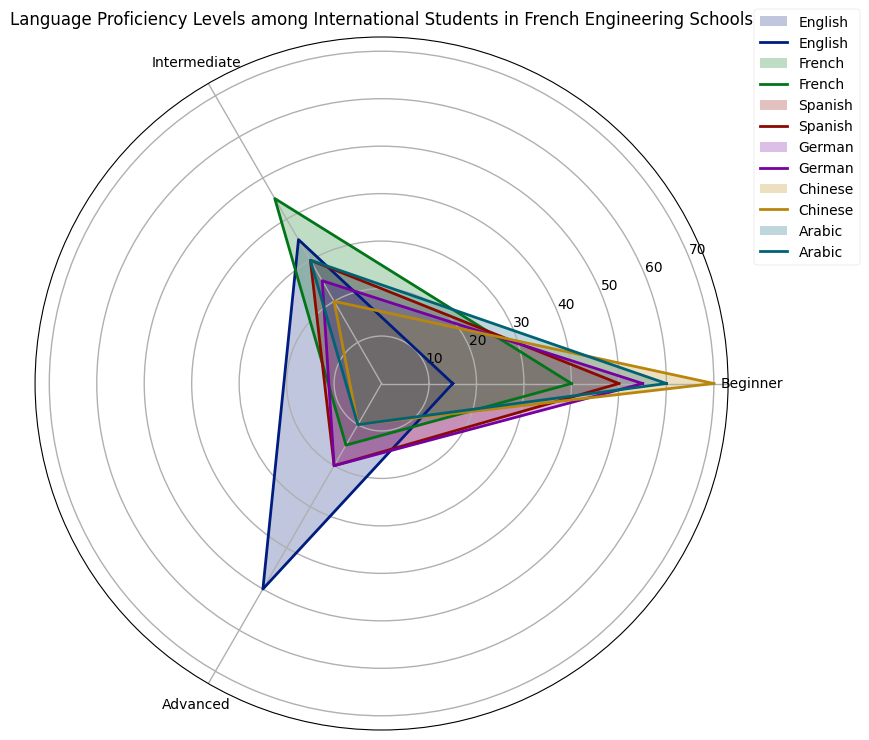What percentage of international students have intermediate proficiency in Chinese? Observe the section of the chart corresponding to Chinese and note the percentage for intermediate proficiency.
Answer: 20 Which language has the highest percentage of students at the beginner level? Compare the beginner proficiency percentages for all languages and identify the largest one.
Answer: Chinese Between Arabic and Spanish, which language has a higher percentage of students with advanced proficiency? Check the advanced proficiency sections for both Arabic and Spanish and compare their percentages.
Answer: Spanish What is the sum of the percentages of students with intermediate proficiency in French and English? Add the intermediate proficiency percentages for both French (45) and English (35). 45 + 35 = 80
Answer: 80 Which language has the lowest percentage of students at the advanced level? Compare the advanced proficiency percentages for all languages to determine the smallest value.
Answer: Chinese How much higher is the percentage of beginner German speakers compared to advanced German speakers? Subtract the advanced German proficiency percentage (20) from the beginner German proficiency percentage (55). 55 - 20 = 35
Answer: 35 What is the average percentage of students with advanced proficiency across all languages? Sum all the advanced proficiency percentages (50 + 15 + 20 + 20 + 10 + 10 = 125) and divide by the number of languages (6). 125 / 6 ≈ 20.83
Answer: 20.83 Which language shows the most balanced distribution across proficiency levels, i.e., the smallest difference between the highest and lowest proficiency percentage? Calculate the difference between the highest and lowest proficiency percentages for each language, and identify the smallest difference.
Answer: Spanish Are there more beginner or advanced French speakers? By how much? Compare the beginner percentage (40) with the advanced percentage (15) for French. Subtract the smaller percentage from the larger one. 40 - 15 = 25
Answer: Beginner by 25 What is the median percentage of students at an intermediate level across all languages? List all intermediate proficiency percentages (35, 45, 30, 25, 20, 30). Arrange them in ascending order (20, 25, 30, 30, 35, 45). The median is the average of the two middle numbers: (30 + 30) / 2 = 30
Answer: 30 